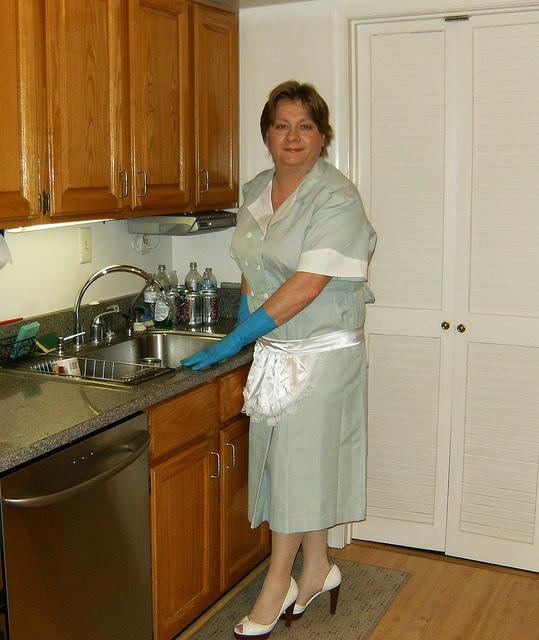Where may this lady be completing the cleaning? kitchen 